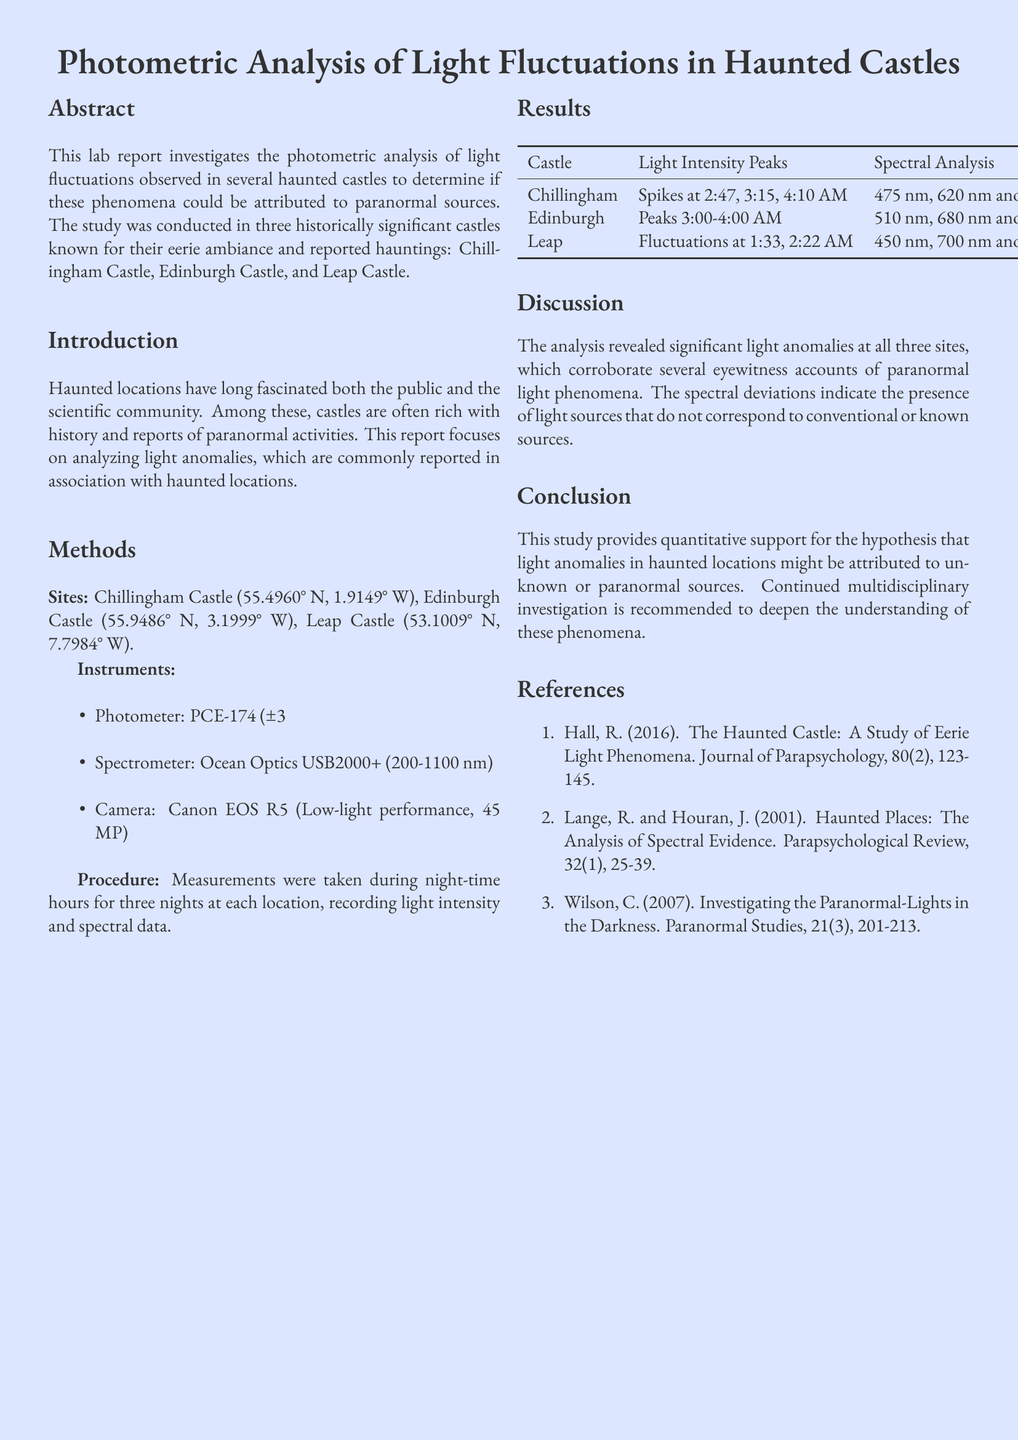what are the names of the castles studied? The report mentions three castles: Chillingham Castle, Edinburgh Castle, and Leap Castle.
Answer: Chillingham Castle, Edinburgh Castle, Leap Castle what instrument was used to measure light intensity? The instrument specifically mentioned for measuring light intensity is the PCE-174 photometer.
Answer: PCE-174 what was the light intensity peak time at Chillingham Castle? The report lists the light intensity peak times at Chillingham Castle as 2:47, 3:15, and 4:10 AM.
Answer: 2:47, 3:15, 4:10 AM what does the spectral analysis reveal at Leap Castle? The spectral analysis at Leap Castle shows anomalies at 450 nm and 700 nm.
Answer: 450 nm, 700 nm how many nights measurements were taken at each location? The report states that measurements were taken for three nights at each location.
Answer: three nights what is the main conclusion of the study? The conclusion states that light anomalies in haunted locations might be attributed to unknown or paranormal sources.
Answer: Unknown or paranormal sources what is the accuracy of the photometer used in the study? The report specifies that the photometer has an accuracy of ±3%.
Answer: ±3% who are the authors referenced in the report? The report lists three authors: Hall, Lange, and Wilson.
Answer: Hall, Lange, Wilson what type of study is this document presenting? The document presents a lab report focused on photometric analysis of light fluctuations.
Answer: Lab report 